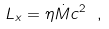<formula> <loc_0><loc_0><loc_500><loc_500>L _ { x } = \eta { \dot { M } } c ^ { 2 } \ ,</formula> 